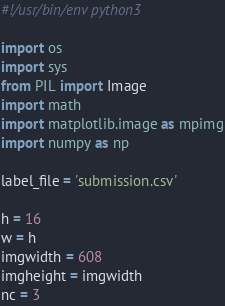<code> <loc_0><loc_0><loc_500><loc_500><_Python_>#!/usr/bin/env python3

import os
import sys
from PIL import Image
import math
import matplotlib.image as mpimg
import numpy as np

label_file = 'submission.csv'

h = 16
w = h
imgwidth = 608
imgheight = imgwidth
nc = 3
</code> 